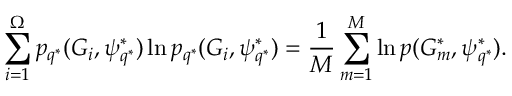<formula> <loc_0><loc_0><loc_500><loc_500>\sum _ { i = 1 } ^ { \Omega } p _ { q ^ { * } } ( G _ { i } , \psi _ { q ^ { * } } ^ { * } ) \ln p _ { q ^ { * } } ( G _ { i } , \psi _ { q ^ { * } } ^ { * } ) = \frac { 1 } { M } \sum _ { m = 1 } ^ { M } \ln p ( G _ { m } ^ { * } , \psi _ { q ^ { * } } ^ { * } ) .</formula> 